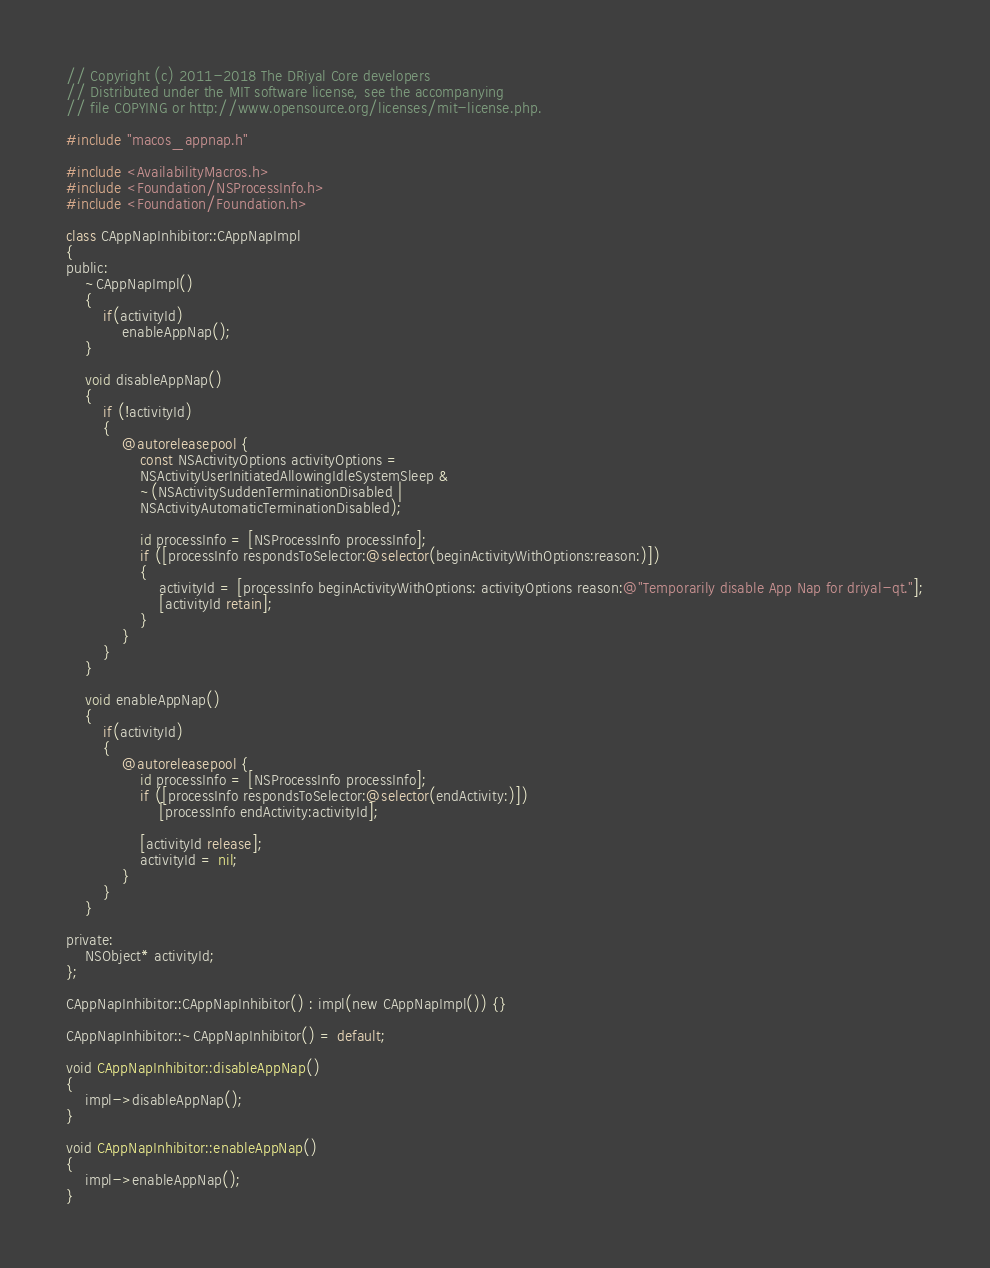Convert code to text. <code><loc_0><loc_0><loc_500><loc_500><_ObjectiveC_>// Copyright (c) 2011-2018 The DRiyal Core developers
// Distributed under the MIT software license, see the accompanying
// file COPYING or http://www.opensource.org/licenses/mit-license.php.

#include "macos_appnap.h"

#include <AvailabilityMacros.h>
#include <Foundation/NSProcessInfo.h>
#include <Foundation/Foundation.h>

class CAppNapInhibitor::CAppNapImpl
{
public:
    ~CAppNapImpl()
    {
        if(activityId)
            enableAppNap();
    }

    void disableAppNap()
    {
        if (!activityId)
        {
            @autoreleasepool {
                const NSActivityOptions activityOptions =
                NSActivityUserInitiatedAllowingIdleSystemSleep &
                ~(NSActivitySuddenTerminationDisabled |
                NSActivityAutomaticTerminationDisabled);

                id processInfo = [NSProcessInfo processInfo];
                if ([processInfo respondsToSelector:@selector(beginActivityWithOptions:reason:)])
                {
                    activityId = [processInfo beginActivityWithOptions: activityOptions reason:@"Temporarily disable App Nap for driyal-qt."];
                    [activityId retain];
                }
            }
        }
    }

    void enableAppNap()
    {
        if(activityId)
        {
            @autoreleasepool {
                id processInfo = [NSProcessInfo processInfo];
                if ([processInfo respondsToSelector:@selector(endActivity:)])
                    [processInfo endActivity:activityId];

                [activityId release];
                activityId = nil;
            }
        }
    }

private:
    NSObject* activityId;
};

CAppNapInhibitor::CAppNapInhibitor() : impl(new CAppNapImpl()) {}

CAppNapInhibitor::~CAppNapInhibitor() = default;

void CAppNapInhibitor::disableAppNap()
{
    impl->disableAppNap();
}

void CAppNapInhibitor::enableAppNap()
{
    impl->enableAppNap();
}
</code> 